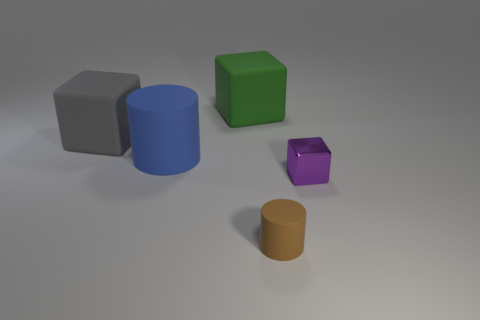Can you describe the lighting and the shadows observed in the scene? The lighting in the scene is soft and diffused, with the shadows of the objects cast slightly to the right, suggesting a light source from the left. The shadows contribute to a sense of depth and positioning of the objects in space. 